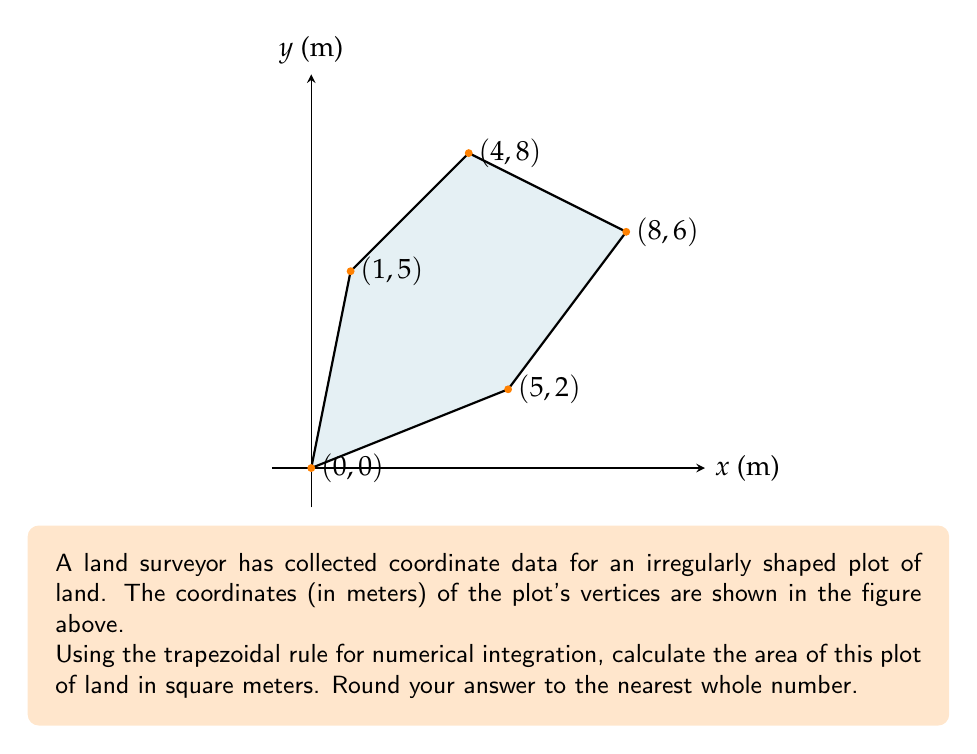Provide a solution to this math problem. To calculate the area of an irregular polygon using coordinate data, we can use the trapezoidal rule for numerical integration. The formula for the area is:

$$ A = \frac{1}{2} \left| \sum_{i=1}^{n} (x_i y_{i+1} - x_{i+1} y_i) \right| $$

Where $(x_i, y_i)$ are the coordinates of the vertices, and $(x_{n+1}, y_{n+1}) = (x_1, y_1)$ to close the polygon.

Let's apply this formula to our data:

1) First, let's organize our data:
   $(x_1, y_1) = (0, 0)$
   $(x_2, y_2) = (5, 2)$
   $(x_3, y_3) = (8, 6)$
   $(x_4, y_4) = (4, 8)$
   $(x_5, y_5) = (1, 5)$
   $(x_6, y_6) = (x_1, y_1) = (0, 0)$ (to close the polygon)

2) Now, let's calculate each term in the sum:
   $x_1y_2 - x_2y_1 = 0(2) - 5(0) = 0$
   $x_2y_3 - x_3y_2 = 5(6) - 8(2) = 14$
   $x_3y_4 - x_4y_3 = 8(8) - 4(6) = 40$
   $x_4y_5 - x_5y_4 = 4(5) - 1(8) = 12$
   $x_5y_6 - x_6y_5 = 1(0) - 0(5) = 0$

3) Sum these terms:
   $0 + 14 + 40 + 12 + 0 = 66$

4) Take the absolute value and divide by 2:
   $A = \frac{1}{2} |66| = 33$

Therefore, the area of the plot is 33 square meters.
Answer: 33 m² 